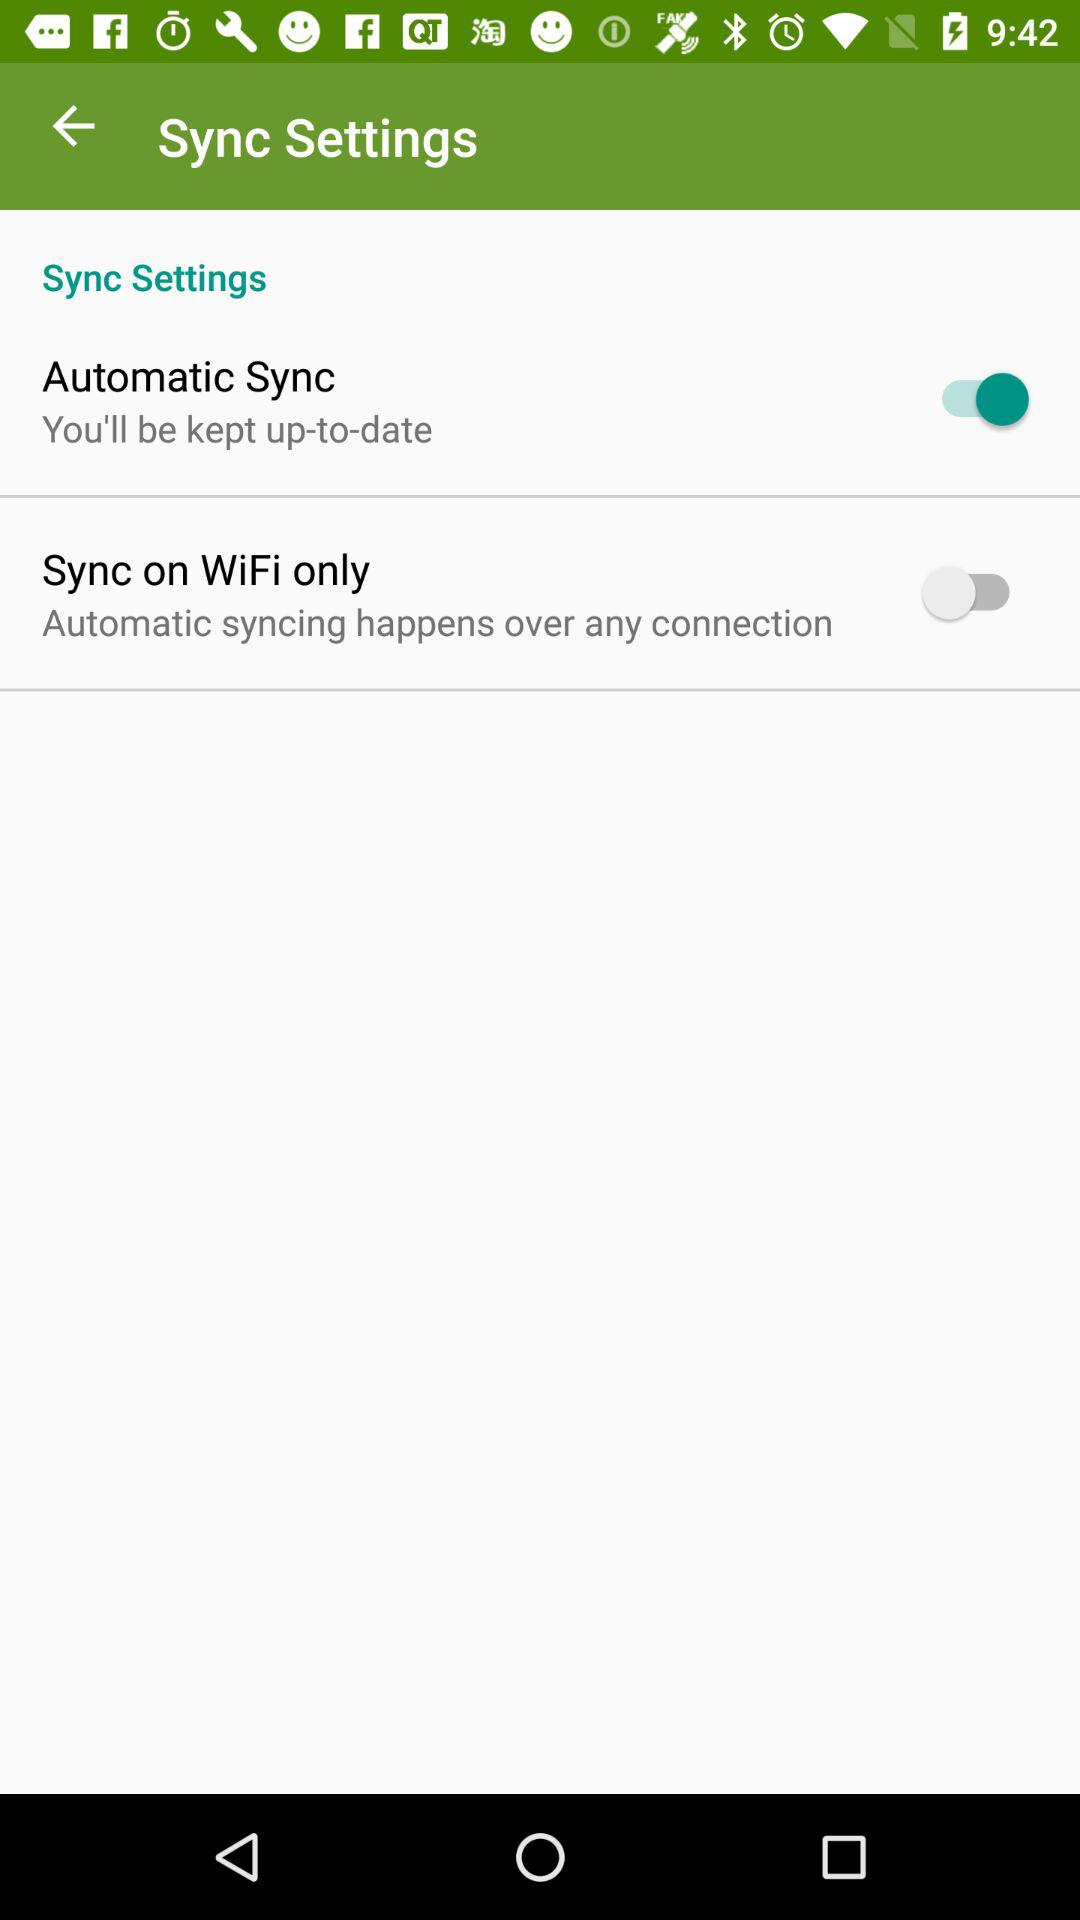Is "Sync Settings" checked or unchecked?
When the provided information is insufficient, respond with <no answer>. <no answer> 